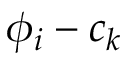<formula> <loc_0><loc_0><loc_500><loc_500>\phi _ { i } - c _ { k }</formula> 